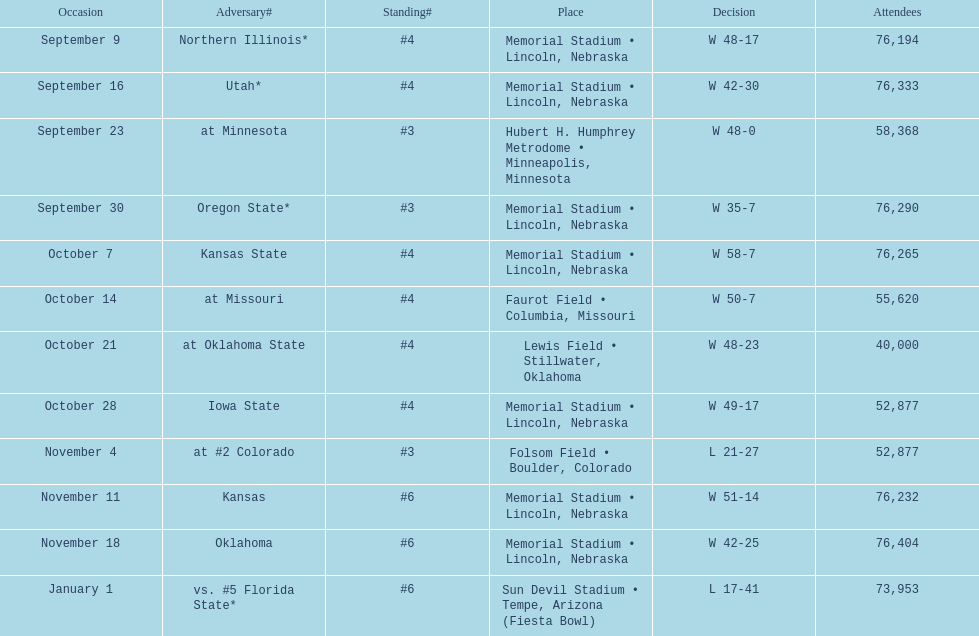When is the first game? September 9. 